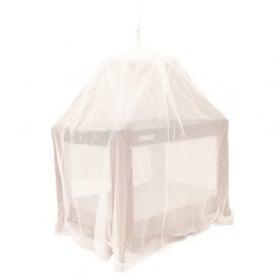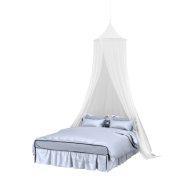The first image is the image on the left, the second image is the image on the right. For the images displayed, is the sentence "The right net/drape has a cone on the top." factually correct? Answer yes or no. Yes. 